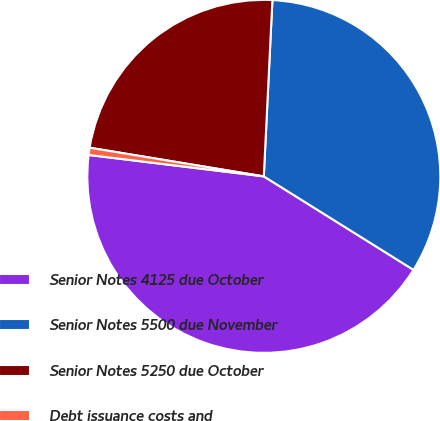<chart> <loc_0><loc_0><loc_500><loc_500><pie_chart><fcel>Senior Notes 4125 due October<fcel>Senior Notes 5500 due November<fcel>Senior Notes 5250 due October<fcel>Debt issuance costs and<nl><fcel>43.05%<fcel>33.11%<fcel>23.18%<fcel>0.66%<nl></chart> 